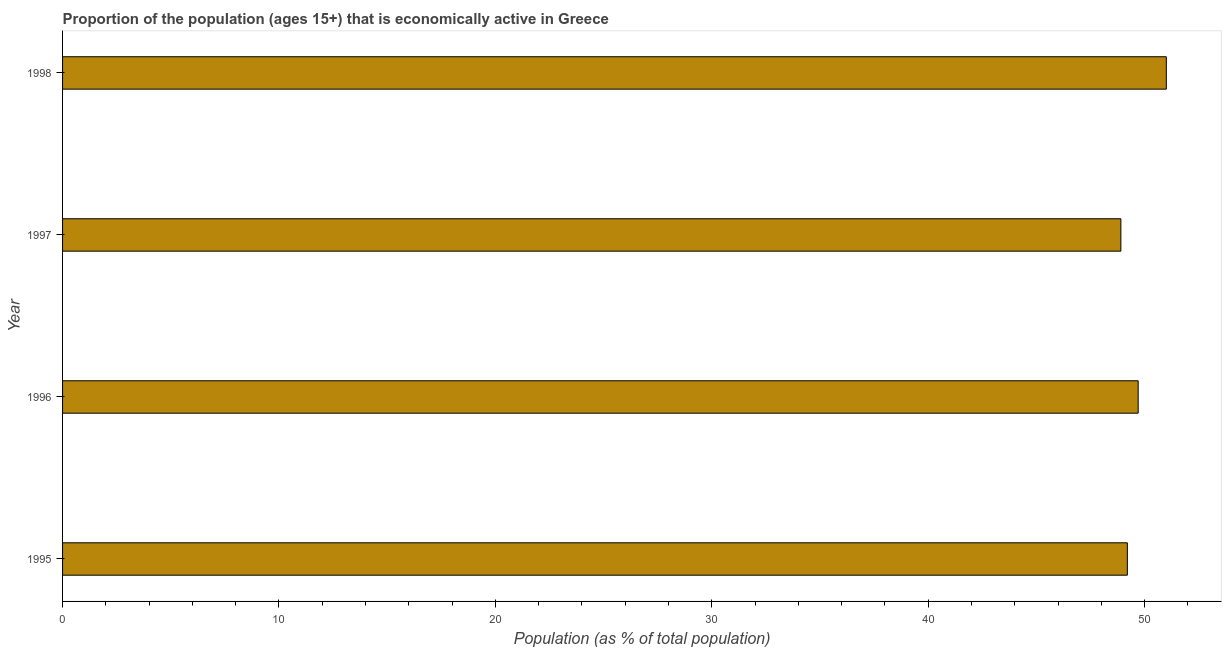Does the graph contain any zero values?
Keep it short and to the point. No. What is the title of the graph?
Offer a very short reply. Proportion of the population (ages 15+) that is economically active in Greece. What is the label or title of the X-axis?
Your answer should be very brief. Population (as % of total population). What is the percentage of economically active population in 1998?
Provide a short and direct response. 51. Across all years, what is the maximum percentage of economically active population?
Give a very brief answer. 51. Across all years, what is the minimum percentage of economically active population?
Your answer should be compact. 48.9. In which year was the percentage of economically active population maximum?
Your answer should be very brief. 1998. In which year was the percentage of economically active population minimum?
Provide a short and direct response. 1997. What is the sum of the percentage of economically active population?
Offer a very short reply. 198.8. What is the difference between the percentage of economically active population in 1995 and 1996?
Provide a short and direct response. -0.5. What is the average percentage of economically active population per year?
Your answer should be compact. 49.7. What is the median percentage of economically active population?
Provide a short and direct response. 49.45. In how many years, is the percentage of economically active population greater than 14 %?
Ensure brevity in your answer.  4. What is the ratio of the percentage of economically active population in 1996 to that in 1998?
Offer a very short reply. 0.97. Is the percentage of economically active population in 1995 less than that in 1997?
Give a very brief answer. No. What is the difference between the highest and the second highest percentage of economically active population?
Give a very brief answer. 1.3. How many bars are there?
Your answer should be very brief. 4. Are all the bars in the graph horizontal?
Give a very brief answer. Yes. What is the difference between two consecutive major ticks on the X-axis?
Give a very brief answer. 10. What is the Population (as % of total population) in 1995?
Your answer should be very brief. 49.2. What is the Population (as % of total population) in 1996?
Offer a very short reply. 49.7. What is the Population (as % of total population) in 1997?
Offer a very short reply. 48.9. What is the Population (as % of total population) of 1998?
Offer a very short reply. 51. What is the difference between the Population (as % of total population) in 1995 and 1996?
Provide a short and direct response. -0.5. What is the difference between the Population (as % of total population) in 1996 and 1997?
Make the answer very short. 0.8. What is the ratio of the Population (as % of total population) in 1996 to that in 1998?
Offer a very short reply. 0.97. What is the ratio of the Population (as % of total population) in 1997 to that in 1998?
Offer a very short reply. 0.96. 